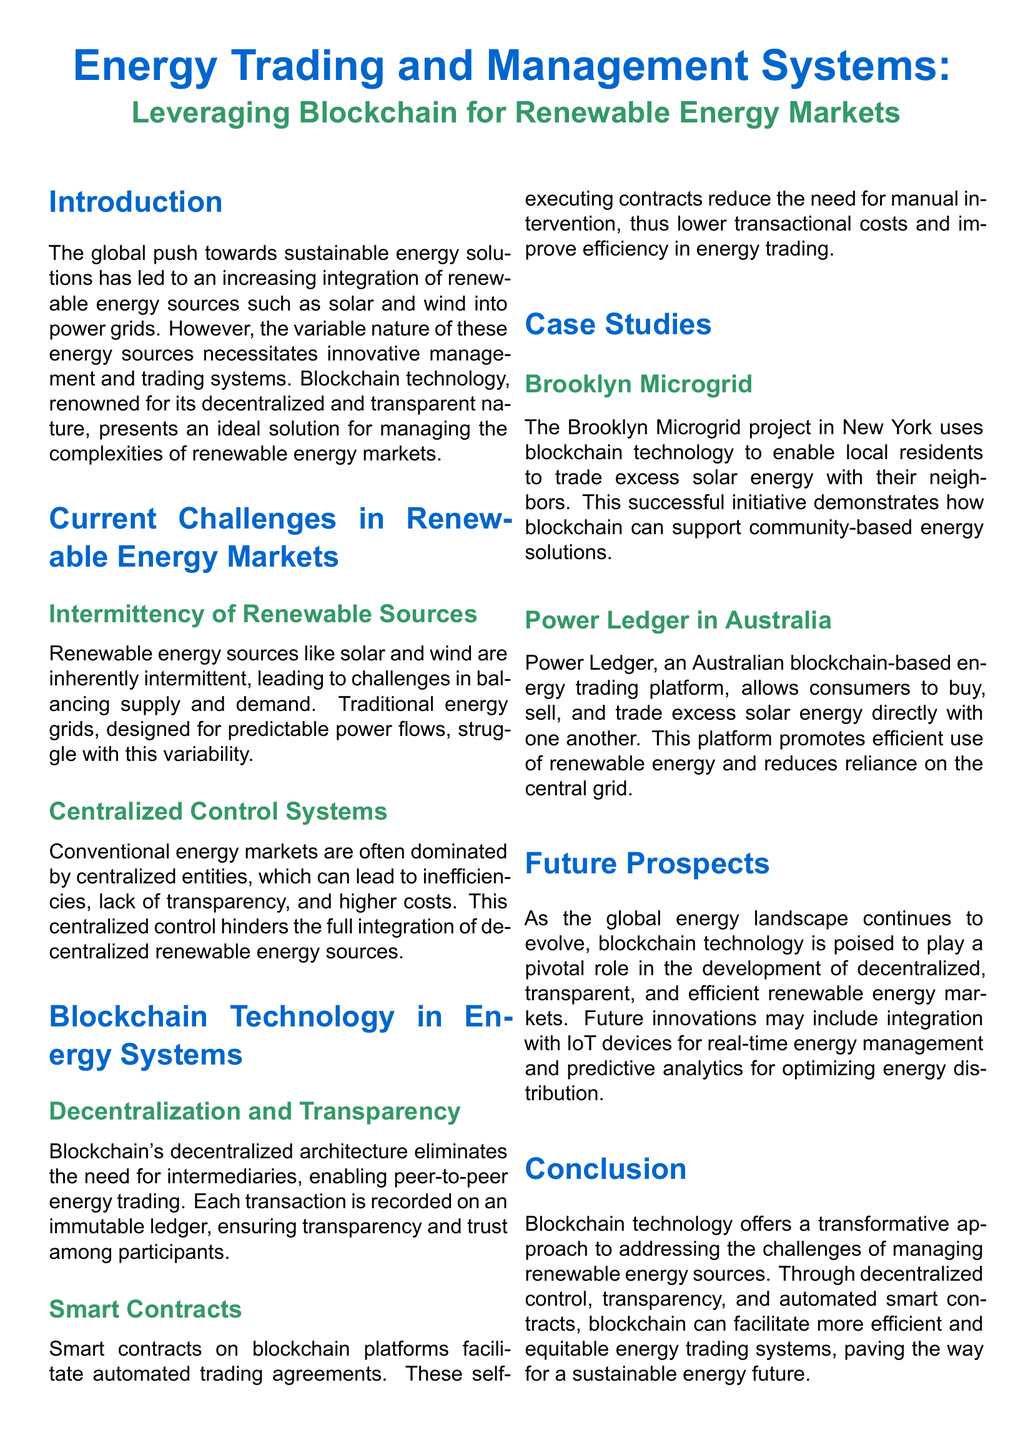What is the main technology discussed in the document? The document focuses on blockchain technology as a solution for energy trading and management.
Answer: blockchain technology What are two examples of blockchain-based energy projects mentioned? The document cites the Brooklyn Microgrid and Power Ledger as examples of blockchain applications in renewable energy.
Answer: Brooklyn Microgrid, Power Ledger What is a main challenge in renewable energy markets? A significant challenge addressed in the document is the intermittency of renewable sources, like solar and wind.
Answer: Intermittency of Renewable Sources What is one benefit of using smart contracts in energy trading? The document states that smart contracts reduce the need for manual intervention, lowering costs and improving efficiency.
Answer: lower costs What future innovation may be integrated with blockchain technology according to the document? The document suggests that future innovations might include integration with IoT devices for real-time energy management.
Answer: IoT devices What is the purpose of the Brooklyn Microgrid project? It enables local residents to trade excess solar energy with their neighbors.
Answer: trading excess solar energy What is the focus of the conclusion in the document? The conclusion emphasizes blockchain's role in providing a transformative approach to renewable energy management and trading.
Answer: transformative approach What type of control does blockchain technology promote in energy systems? The document states that blockchain promotes decentralized control in energy trading systems.
Answer: decentralized control 